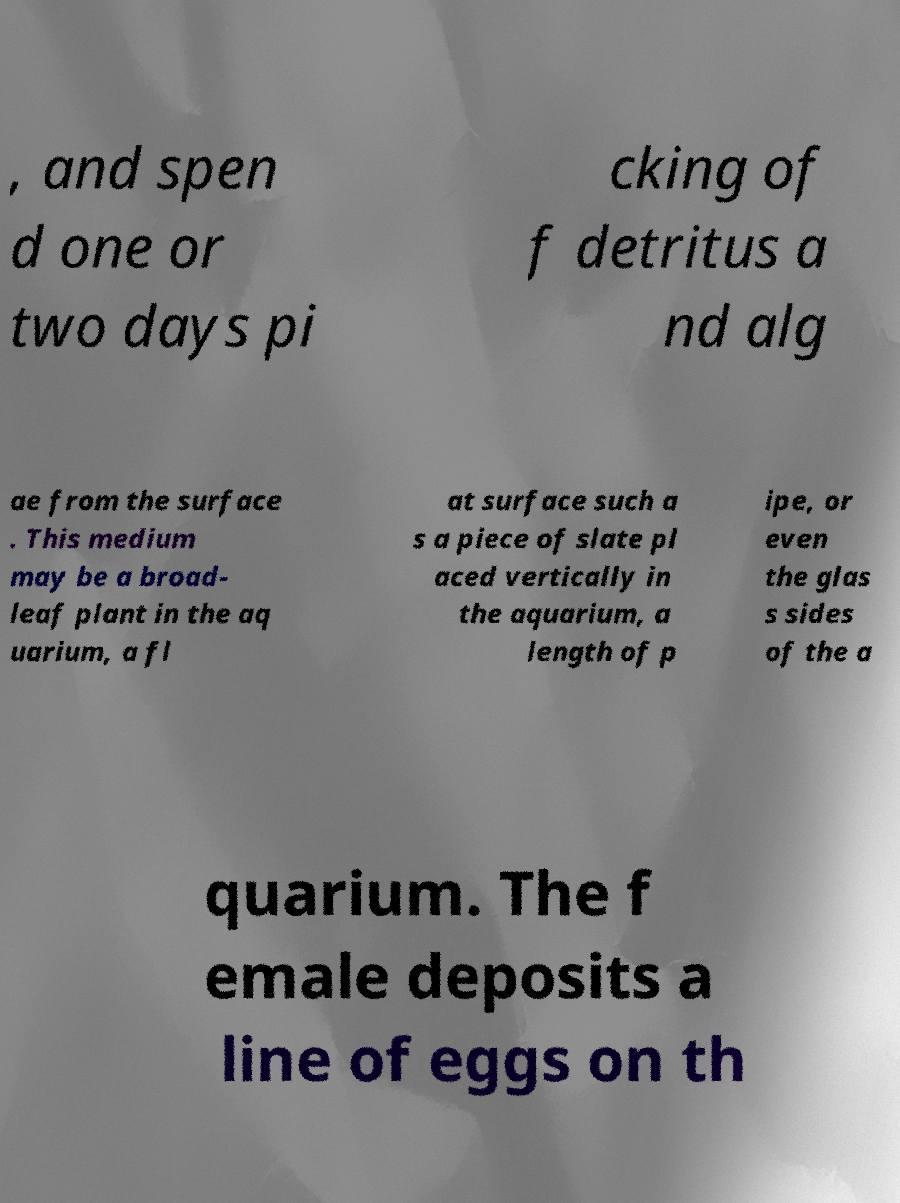Can you read and provide the text displayed in the image?This photo seems to have some interesting text. Can you extract and type it out for me? , and spen d one or two days pi cking of f detritus a nd alg ae from the surface . This medium may be a broad- leaf plant in the aq uarium, a fl at surface such a s a piece of slate pl aced vertically in the aquarium, a length of p ipe, or even the glas s sides of the a quarium. The f emale deposits a line of eggs on th 